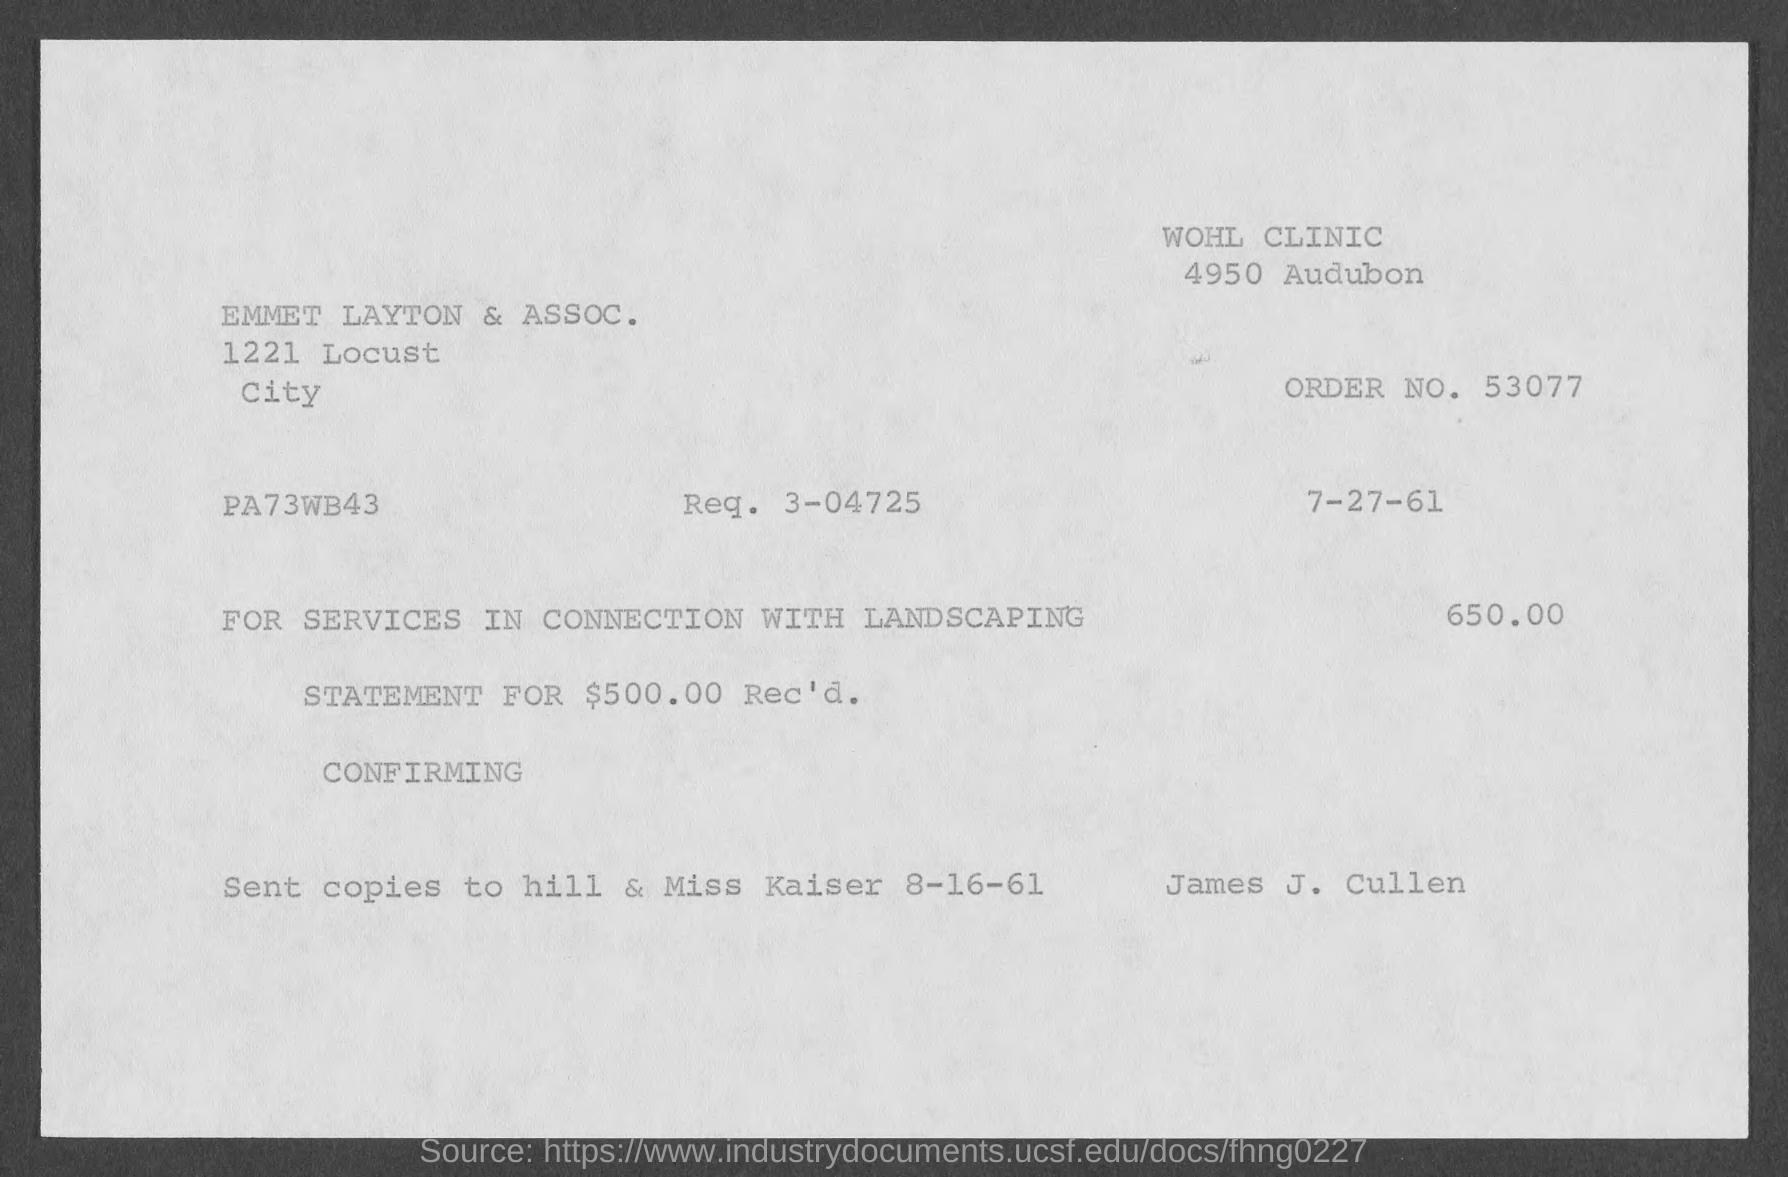What is the issued date of the invoice?
Ensure brevity in your answer.  7-27-61. What is the Order No. given in the invoice?
Offer a terse response. 53077. What is the Req. No. given in the invoice?
Ensure brevity in your answer.  3-04725. Which company is raising the invoice?
Keep it short and to the point. EMMET LAYTON & ASSOC. What is the invoice amount given in the document?
Offer a terse response. 650.00. 